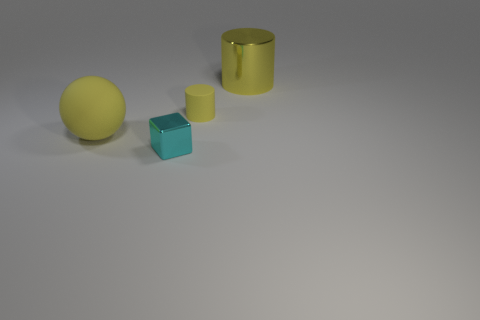What color is the rubber cylinder that is the same size as the cyan object?
Your response must be concise. Yellow. Are there any small cylinders of the same color as the big cylinder?
Your answer should be compact. Yes. What is the size of the yellow cylinder that is made of the same material as the big yellow sphere?
Your answer should be compact. Small. There is a rubber object that is the same color as the rubber cylinder; what is its size?
Offer a terse response. Large. There is a yellow cylinder in front of the large shiny cylinder; what is its material?
Offer a terse response. Rubber. The rubber thing that is on the right side of the metal thing in front of the yellow thing that is on the left side of the small cyan shiny cube is what shape?
Offer a terse response. Cylinder. Is the size of the rubber ball the same as the yellow matte cylinder?
Provide a short and direct response. No. What number of objects are shiny things or metal objects that are in front of the yellow ball?
Provide a short and direct response. 2. What number of objects are matte things behind the large yellow ball or small objects on the left side of the small yellow object?
Offer a terse response. 2. There is a tiny rubber thing; are there any large yellow balls right of it?
Make the answer very short. No. 